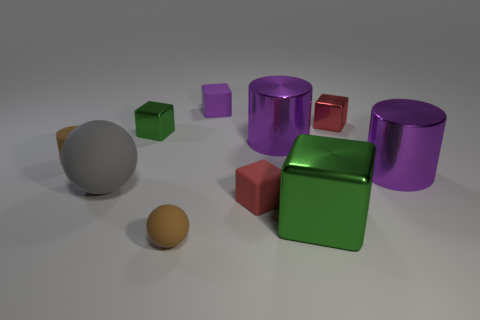Subtract all yellow balls. How many purple cylinders are left? 2 Subtract 1 cubes. How many cubes are left? 4 Subtract all green blocks. How many blocks are left? 3 Subtract all large metal blocks. How many blocks are left? 4 Subtract all cyan blocks. Subtract all purple cylinders. How many blocks are left? 5 Subtract all cylinders. How many objects are left? 7 Subtract all gray metal cylinders. Subtract all big purple metallic cylinders. How many objects are left? 8 Add 2 rubber things. How many rubber things are left? 7 Add 4 small red rubber spheres. How many small red rubber spheres exist? 4 Subtract 0 red spheres. How many objects are left? 10 